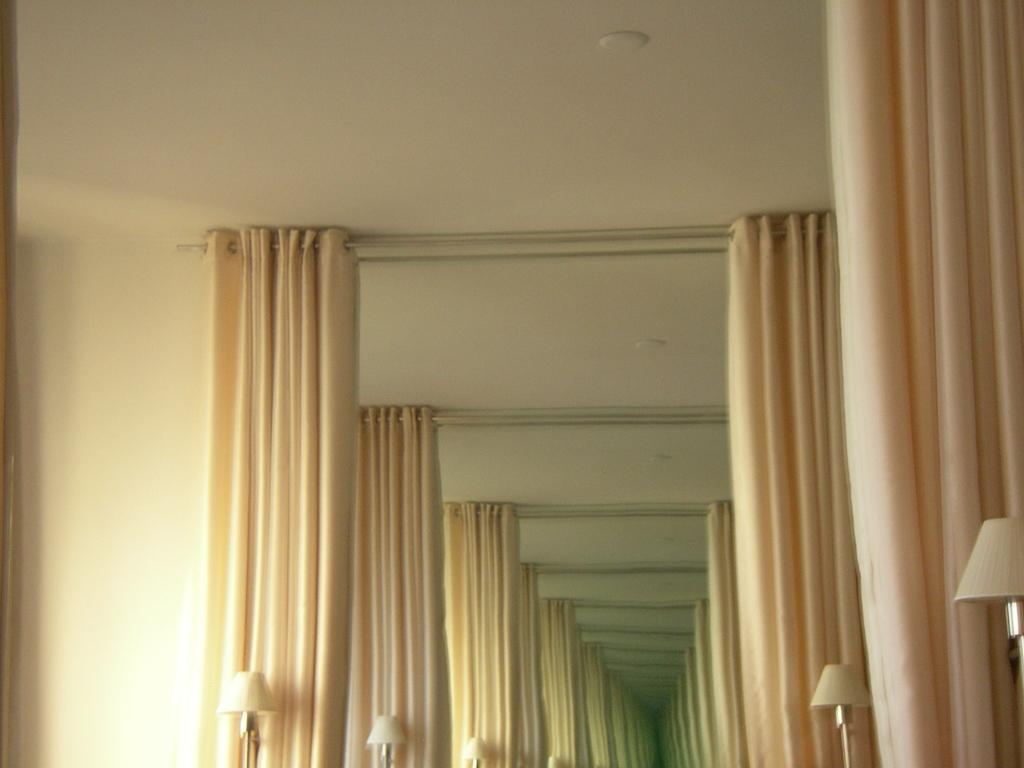What color is the wall in the image? The wall in the image is cream colored. What color are the curtains in the image? The curtains in the image are also cream colored. What type of lighting is present in the image? There are lamps in the image. Can you describe the presence of multiple images in the image? There are multiple reflections of the same image in the form of reflections. How does the wall in the image turn into quicksand? The wall in the image does not turn into quicksand; it remains a solid, cream-colored wall. 